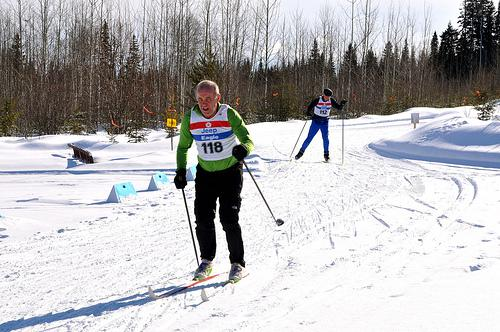Question: what is on the ground?
Choices:
A. Litter.
B. Snow.
C. A plague of frogs.
D. Floodwaters.
Answer with the letter. Answer: B Question: how many people can be seen?
Choices:
A. 3.
B. 4.
C. Around 15.
D. 2.
Answer with the letter. Answer: D Question: what are the people doing?
Choices:
A. Singing in a barbershop quartet.
B. Skiing.
C. Robbing a bank.
D. Rescuing kittens from a tree.
Answer with the letter. Answer: B Question: what color shirt is 118 wearing?
Choices:
A. Blue.
B. Pink.
C. Green.
D. Yellow.
Answer with the letter. Answer: C Question: what color signs are the men wearing?
Choices:
A. Blue.
B. Green.
C. Purple.
D. White.
Answer with the letter. Answer: D 